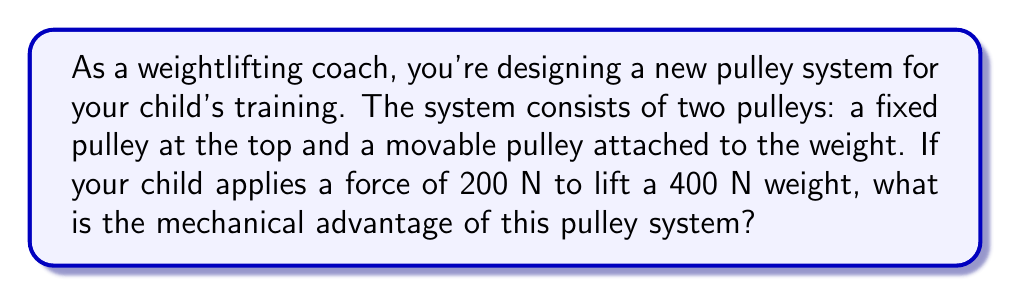Provide a solution to this math problem. Let's approach this step-by-step:

1) The mechanical advantage (MA) of a pulley system is defined as the ratio of the output force (load) to the input force (effort):

   $$ MA = \frac{F_{out}}{F_{in}} $$

2) In this case:
   $F_{out}$ = 400 N (the weight being lifted)
   $F_{in}$ = 200 N (the force applied by your child)

3) For a system with one fixed pulley and one movable pulley:
   - The fixed pulley changes the direction of the force but doesn't provide mechanical advantage.
   - The movable pulley splits the weight between two supporting strands of rope.

4) This setup effectively halves the force needed to lift the weight, which is why your child can lift a 400 N weight with only 200 N of force.

5) Plugging these values into our equation:

   $$ MA = \frac{400 \text{ N}}{200 \text{ N}} = 2 $$

Therefore, the mechanical advantage of this pulley system is 2.
Answer: 2 